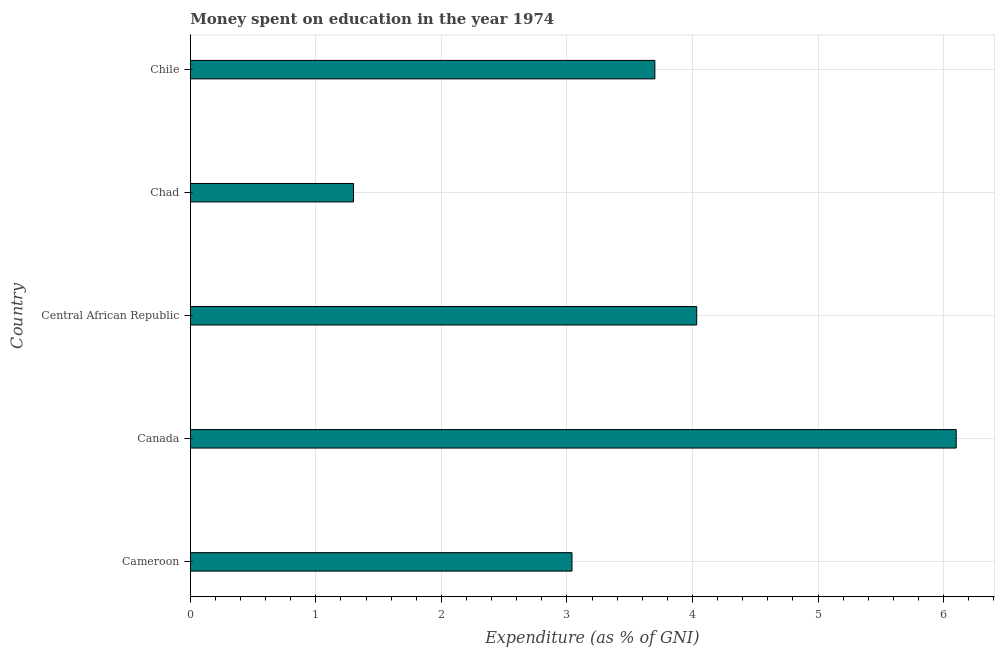Does the graph contain any zero values?
Give a very brief answer. No. Does the graph contain grids?
Provide a succinct answer. Yes. What is the title of the graph?
Provide a short and direct response. Money spent on education in the year 1974. What is the label or title of the X-axis?
Ensure brevity in your answer.  Expenditure (as % of GNI). What is the label or title of the Y-axis?
Offer a very short reply. Country. What is the expenditure on education in Cameroon?
Keep it short and to the point. 3.04. In which country was the expenditure on education maximum?
Give a very brief answer. Canada. In which country was the expenditure on education minimum?
Offer a very short reply. Chad. What is the sum of the expenditure on education?
Offer a very short reply. 18.17. What is the average expenditure on education per country?
Your answer should be compact. 3.63. What is the ratio of the expenditure on education in Cameroon to that in Central African Republic?
Your answer should be very brief. 0.75. Is the expenditure on education in Cameroon less than that in Chile?
Ensure brevity in your answer.  Yes. Is the difference between the expenditure on education in Central African Republic and Chad greater than the difference between any two countries?
Your response must be concise. No. What is the difference between the highest and the second highest expenditure on education?
Ensure brevity in your answer.  2.07. What is the difference between the highest and the lowest expenditure on education?
Your answer should be very brief. 4.8. What is the difference between two consecutive major ticks on the X-axis?
Keep it short and to the point. 1. Are the values on the major ticks of X-axis written in scientific E-notation?
Your response must be concise. No. What is the Expenditure (as % of GNI) of Cameroon?
Your answer should be very brief. 3.04. What is the Expenditure (as % of GNI) in Central African Republic?
Give a very brief answer. 4.03. What is the Expenditure (as % of GNI) of Chad?
Offer a terse response. 1.3. What is the Expenditure (as % of GNI) of Chile?
Make the answer very short. 3.7. What is the difference between the Expenditure (as % of GNI) in Cameroon and Canada?
Make the answer very short. -3.06. What is the difference between the Expenditure (as % of GNI) in Cameroon and Central African Republic?
Offer a very short reply. -0.99. What is the difference between the Expenditure (as % of GNI) in Cameroon and Chad?
Give a very brief answer. 1.74. What is the difference between the Expenditure (as % of GNI) in Cameroon and Chile?
Your answer should be very brief. -0.66. What is the difference between the Expenditure (as % of GNI) in Canada and Central African Republic?
Offer a terse response. 2.07. What is the difference between the Expenditure (as % of GNI) in Canada and Chad?
Your answer should be compact. 4.8. What is the difference between the Expenditure (as % of GNI) in Canada and Chile?
Your answer should be compact. 2.4. What is the difference between the Expenditure (as % of GNI) in Central African Republic and Chad?
Make the answer very short. 2.73. What is the difference between the Expenditure (as % of GNI) in Central African Republic and Chile?
Offer a very short reply. 0.33. What is the difference between the Expenditure (as % of GNI) in Chad and Chile?
Give a very brief answer. -2.4. What is the ratio of the Expenditure (as % of GNI) in Cameroon to that in Canada?
Offer a terse response. 0.5. What is the ratio of the Expenditure (as % of GNI) in Cameroon to that in Central African Republic?
Ensure brevity in your answer.  0.75. What is the ratio of the Expenditure (as % of GNI) in Cameroon to that in Chad?
Your answer should be compact. 2.34. What is the ratio of the Expenditure (as % of GNI) in Cameroon to that in Chile?
Ensure brevity in your answer.  0.82. What is the ratio of the Expenditure (as % of GNI) in Canada to that in Central African Republic?
Keep it short and to the point. 1.51. What is the ratio of the Expenditure (as % of GNI) in Canada to that in Chad?
Provide a succinct answer. 4.69. What is the ratio of the Expenditure (as % of GNI) in Canada to that in Chile?
Your answer should be very brief. 1.65. What is the ratio of the Expenditure (as % of GNI) in Central African Republic to that in Chad?
Ensure brevity in your answer.  3.1. What is the ratio of the Expenditure (as % of GNI) in Central African Republic to that in Chile?
Offer a terse response. 1.09. What is the ratio of the Expenditure (as % of GNI) in Chad to that in Chile?
Give a very brief answer. 0.35. 